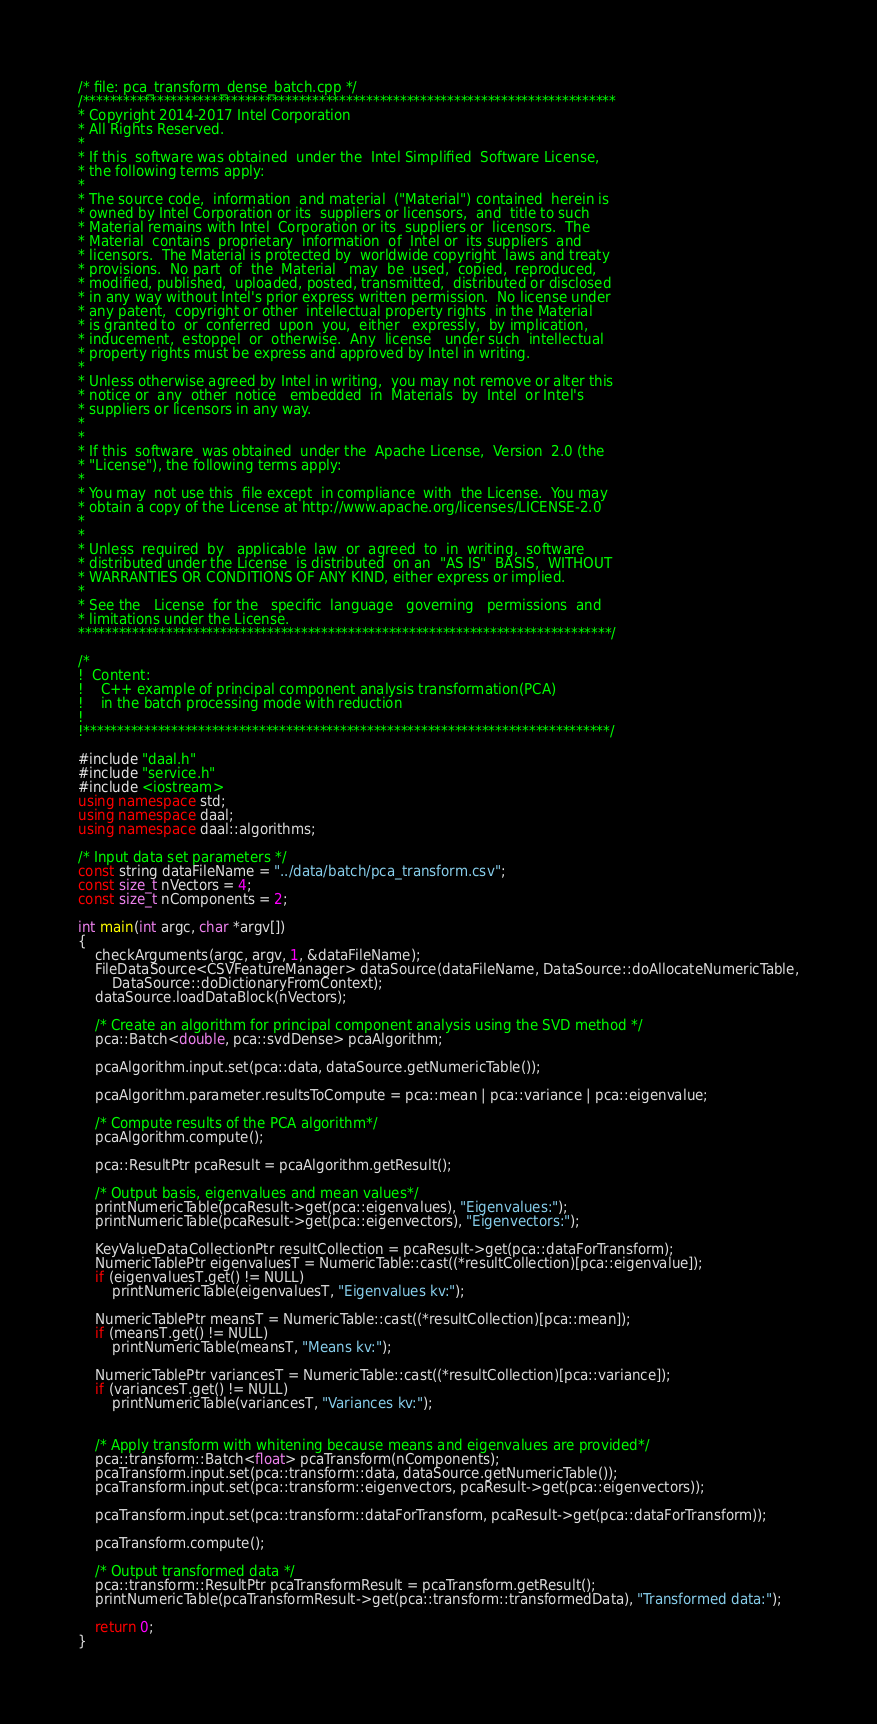<code> <loc_0><loc_0><loc_500><loc_500><_C++_>/* file: pca_transform_dense_batch.cpp */
/*******************************************************************************
* Copyright 2014-2017 Intel Corporation
* All Rights Reserved.
*
* If this  software was obtained  under the  Intel Simplified  Software License,
* the following terms apply:
*
* The source code,  information  and material  ("Material") contained  herein is
* owned by Intel Corporation or its  suppliers or licensors,  and  title to such
* Material remains with Intel  Corporation or its  suppliers or  licensors.  The
* Material  contains  proprietary  information  of  Intel or  its suppliers  and
* licensors.  The Material is protected by  worldwide copyright  laws and treaty
* provisions.  No part  of  the  Material   may  be  used,  copied,  reproduced,
* modified, published,  uploaded, posted, transmitted,  distributed or disclosed
* in any way without Intel's prior express written permission.  No license under
* any patent,  copyright or other  intellectual property rights  in the Material
* is granted to  or  conferred  upon  you,  either   expressly,  by implication,
* inducement,  estoppel  or  otherwise.  Any  license   under such  intellectual
* property rights must be express and approved by Intel in writing.
*
* Unless otherwise agreed by Intel in writing,  you may not remove or alter this
* notice or  any  other  notice   embedded  in  Materials  by  Intel  or Intel's
* suppliers or licensors in any way.
*
*
* If this  software  was obtained  under the  Apache License,  Version  2.0 (the
* "License"), the following terms apply:
*
* You may  not use this  file except  in compliance  with  the License.  You may
* obtain a copy of the License at http://www.apache.org/licenses/LICENSE-2.0
*
*
* Unless  required  by   applicable  law  or  agreed  to  in  writing,  software
* distributed under the License  is distributed  on an  "AS IS"  BASIS,  WITHOUT
* WARRANTIES OR CONDITIONS OF ANY KIND, either express or implied.
*
* See the   License  for the   specific  language   governing   permissions  and
* limitations under the License.
*******************************************************************************/

/*
!  Content:
!    C++ example of principal component analysis transformation(PCA)
!    in the batch processing mode with reduction
!
!******************************************************************************/

#include "daal.h"
#include "service.h"
#include <iostream>
using namespace std;
using namespace daal;
using namespace daal::algorithms;

/* Input data set parameters */
const string dataFileName = "../data/batch/pca_transform.csv";
const size_t nVectors = 4;
const size_t nComponents = 2;

int main(int argc, char *argv[])
{
    checkArguments(argc, argv, 1, &dataFileName);
    FileDataSource<CSVFeatureManager> dataSource(dataFileName, DataSource::doAllocateNumericTable,
        DataSource::doDictionaryFromContext);
    dataSource.loadDataBlock(nVectors);

    /* Create an algorithm for principal component analysis using the SVD method */
    pca::Batch<double, pca::svdDense> pcaAlgorithm;

    pcaAlgorithm.input.set(pca::data, dataSource.getNumericTable());

    pcaAlgorithm.parameter.resultsToCompute = pca::mean | pca::variance | pca::eigenvalue;

    /* Compute results of the PCA algorithm*/
    pcaAlgorithm.compute();

    pca::ResultPtr pcaResult = pcaAlgorithm.getResult();

    /* Output basis, eigenvalues and mean values*/
    printNumericTable(pcaResult->get(pca::eigenvalues), "Eigenvalues:");
    printNumericTable(pcaResult->get(pca::eigenvectors), "Eigenvectors:");

    KeyValueDataCollectionPtr resultCollection = pcaResult->get(pca::dataForTransform);
    NumericTablePtr eigenvaluesT = NumericTable::cast((*resultCollection)[pca::eigenvalue]);
    if (eigenvaluesT.get() != NULL)
        printNumericTable(eigenvaluesT, "Eigenvalues kv:");

    NumericTablePtr meansT = NumericTable::cast((*resultCollection)[pca::mean]);
    if (meansT.get() != NULL)
        printNumericTable(meansT, "Means kv:");

    NumericTablePtr variancesT = NumericTable::cast((*resultCollection)[pca::variance]);
    if (variancesT.get() != NULL)
        printNumericTable(variancesT, "Variances kv:");


    /* Apply transform with whitening because means and eigenvalues are provided*/
    pca::transform::Batch<float> pcaTransform(nComponents);
    pcaTransform.input.set(pca::transform::data, dataSource.getNumericTable());
    pcaTransform.input.set(pca::transform::eigenvectors, pcaResult->get(pca::eigenvectors));

    pcaTransform.input.set(pca::transform::dataForTransform, pcaResult->get(pca::dataForTransform));

    pcaTransform.compute();

    /* Output transformed data */
    pca::transform::ResultPtr pcaTransformResult = pcaTransform.getResult();
    printNumericTable(pcaTransformResult->get(pca::transform::transformedData), "Transformed data:");

    return 0;
}
</code> 